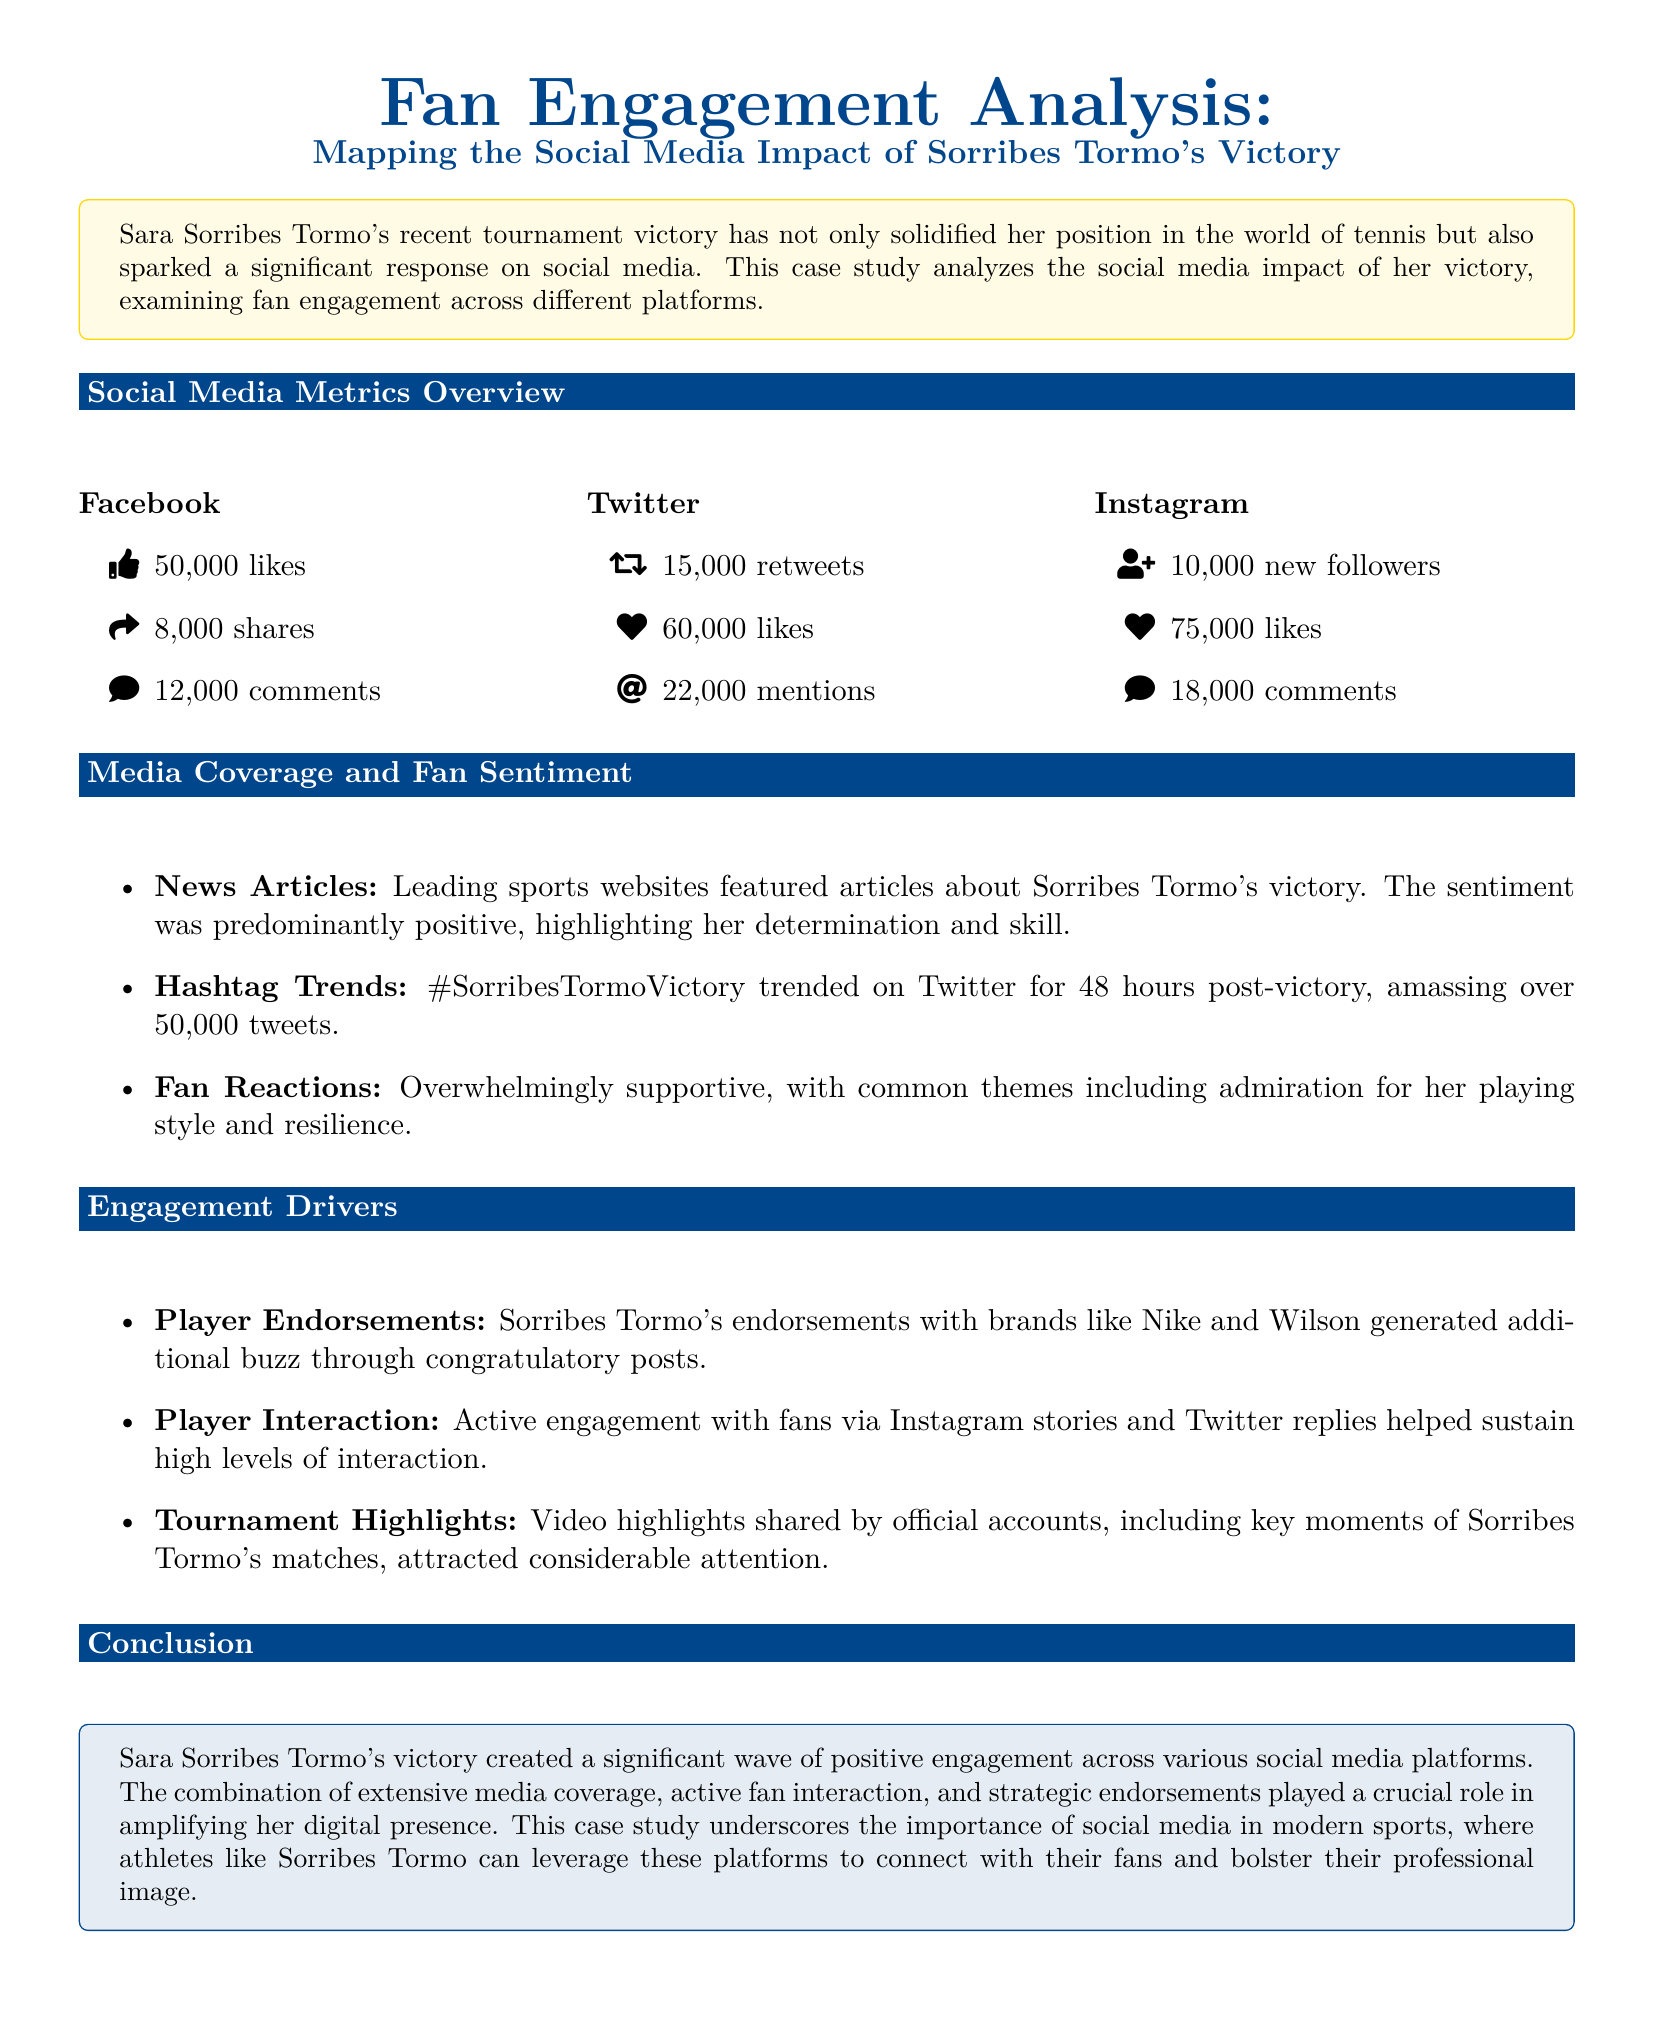What is the total number of likes on Twitter? The total number of likes on Twitter is found in the metrics, which states 60,000 likes.
Answer: 60,000 How many shares did Sorribes Tormo's Facebook post receive? The document states that Sorribes Tormo's Facebook post received 8,000 shares.
Answer: 8,000 What was the sentiment of the media coverage? The sentiment of the media coverage is described as predominantly positive.
Answer: Positive How many tweets did the hashtag trend generate? The hashtag generated over 50,000 tweets as mentioned in the document.
Answer: 50,000 What was one of the engagement drivers mentioned? The document lists player endorsements as one of the engagement drivers.
Answer: Player endorsements How many new followers did Sorribes Tormo gain on Instagram? The document indicates that she gained 10,000 new followers on Instagram.
Answer: 10,000 What brand does Sorribes Tormo have an endorsement with? The document mentions Nike as one of the brands she is endorsed by.
Answer: Nike How long did the hashtag trend on Twitter? The document states that the hashtag trended for 48 hours post-victory.
Answer: 48 hours 